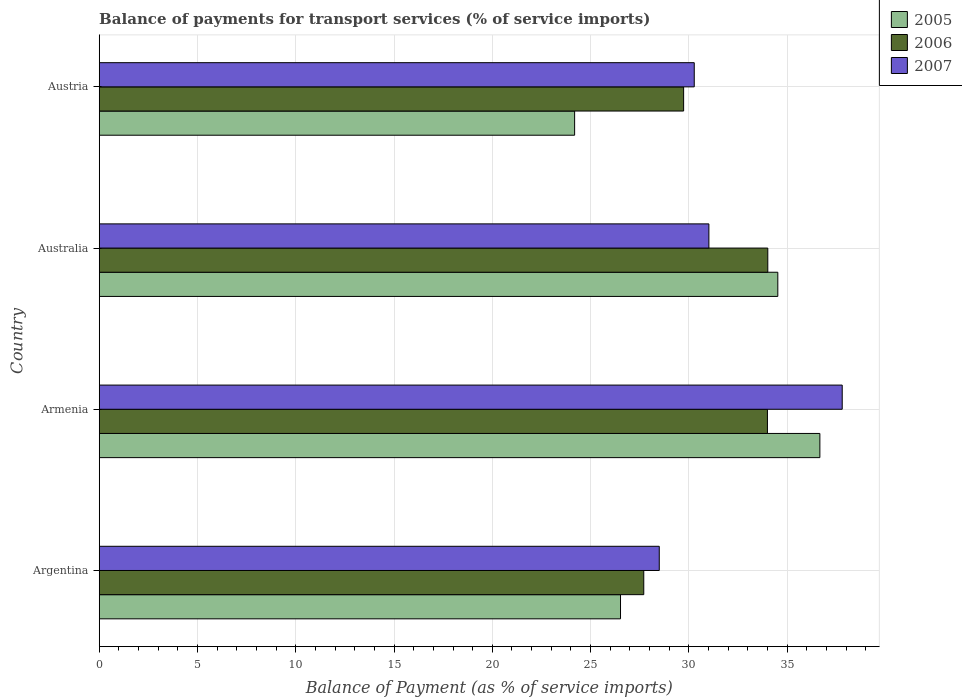How many different coloured bars are there?
Provide a succinct answer. 3. How many groups of bars are there?
Make the answer very short. 4. Are the number of bars on each tick of the Y-axis equal?
Offer a terse response. Yes. How many bars are there on the 1st tick from the bottom?
Your answer should be very brief. 3. In how many cases, is the number of bars for a given country not equal to the number of legend labels?
Your answer should be very brief. 0. What is the balance of payments for transport services in 2006 in Austria?
Your response must be concise. 29.73. Across all countries, what is the maximum balance of payments for transport services in 2006?
Your answer should be compact. 34.02. Across all countries, what is the minimum balance of payments for transport services in 2007?
Make the answer very short. 28.49. In which country was the balance of payments for transport services in 2005 maximum?
Provide a short and direct response. Armenia. What is the total balance of payments for transport services in 2006 in the graph?
Your response must be concise. 125.45. What is the difference between the balance of payments for transport services in 2007 in Argentina and that in Australia?
Make the answer very short. -2.53. What is the difference between the balance of payments for transport services in 2007 in Austria and the balance of payments for transport services in 2005 in Australia?
Provide a short and direct response. -4.25. What is the average balance of payments for transport services in 2007 per country?
Offer a very short reply. 31.9. What is the difference between the balance of payments for transport services in 2006 and balance of payments for transport services in 2005 in Armenia?
Keep it short and to the point. -2.67. In how many countries, is the balance of payments for transport services in 2006 greater than 14 %?
Your response must be concise. 4. What is the ratio of the balance of payments for transport services in 2007 in Armenia to that in Austria?
Provide a short and direct response. 1.25. What is the difference between the highest and the second highest balance of payments for transport services in 2006?
Ensure brevity in your answer.  0.02. What is the difference between the highest and the lowest balance of payments for transport services in 2005?
Provide a succinct answer. 12.48. What does the 1st bar from the bottom in Armenia represents?
Ensure brevity in your answer.  2005. Is it the case that in every country, the sum of the balance of payments for transport services in 2005 and balance of payments for transport services in 2006 is greater than the balance of payments for transport services in 2007?
Offer a terse response. Yes. How many bars are there?
Your answer should be compact. 12. Are all the bars in the graph horizontal?
Give a very brief answer. Yes. Are the values on the major ticks of X-axis written in scientific E-notation?
Provide a succinct answer. No. How many legend labels are there?
Provide a short and direct response. 3. How are the legend labels stacked?
Give a very brief answer. Vertical. What is the title of the graph?
Ensure brevity in your answer.  Balance of payments for transport services (% of service imports). What is the label or title of the X-axis?
Provide a succinct answer. Balance of Payment (as % of service imports). What is the label or title of the Y-axis?
Your response must be concise. Country. What is the Balance of Payment (as % of service imports) of 2005 in Argentina?
Your response must be concise. 26.52. What is the Balance of Payment (as % of service imports) of 2006 in Argentina?
Provide a short and direct response. 27.71. What is the Balance of Payment (as % of service imports) of 2007 in Argentina?
Keep it short and to the point. 28.49. What is the Balance of Payment (as % of service imports) in 2005 in Armenia?
Your answer should be very brief. 36.67. What is the Balance of Payment (as % of service imports) of 2006 in Armenia?
Offer a very short reply. 34. What is the Balance of Payment (as % of service imports) in 2007 in Armenia?
Ensure brevity in your answer.  37.8. What is the Balance of Payment (as % of service imports) in 2005 in Australia?
Provide a succinct answer. 34.53. What is the Balance of Payment (as % of service imports) of 2006 in Australia?
Provide a short and direct response. 34.02. What is the Balance of Payment (as % of service imports) of 2007 in Australia?
Keep it short and to the point. 31.02. What is the Balance of Payment (as % of service imports) in 2005 in Austria?
Your answer should be very brief. 24.19. What is the Balance of Payment (as % of service imports) of 2006 in Austria?
Your answer should be very brief. 29.73. What is the Balance of Payment (as % of service imports) of 2007 in Austria?
Your answer should be very brief. 30.27. Across all countries, what is the maximum Balance of Payment (as % of service imports) in 2005?
Provide a short and direct response. 36.67. Across all countries, what is the maximum Balance of Payment (as % of service imports) of 2006?
Provide a succinct answer. 34.02. Across all countries, what is the maximum Balance of Payment (as % of service imports) of 2007?
Provide a succinct answer. 37.8. Across all countries, what is the minimum Balance of Payment (as % of service imports) of 2005?
Your response must be concise. 24.19. Across all countries, what is the minimum Balance of Payment (as % of service imports) in 2006?
Ensure brevity in your answer.  27.71. Across all countries, what is the minimum Balance of Payment (as % of service imports) in 2007?
Offer a very short reply. 28.49. What is the total Balance of Payment (as % of service imports) of 2005 in the graph?
Keep it short and to the point. 121.9. What is the total Balance of Payment (as % of service imports) in 2006 in the graph?
Offer a very short reply. 125.45. What is the total Balance of Payment (as % of service imports) of 2007 in the graph?
Provide a short and direct response. 127.59. What is the difference between the Balance of Payment (as % of service imports) in 2005 in Argentina and that in Armenia?
Offer a very short reply. -10.14. What is the difference between the Balance of Payment (as % of service imports) of 2006 in Argentina and that in Armenia?
Keep it short and to the point. -6.29. What is the difference between the Balance of Payment (as % of service imports) in 2007 in Argentina and that in Armenia?
Keep it short and to the point. -9.31. What is the difference between the Balance of Payment (as % of service imports) in 2005 in Argentina and that in Australia?
Offer a very short reply. -8. What is the difference between the Balance of Payment (as % of service imports) in 2006 in Argentina and that in Australia?
Your answer should be compact. -6.31. What is the difference between the Balance of Payment (as % of service imports) of 2007 in Argentina and that in Australia?
Your answer should be very brief. -2.53. What is the difference between the Balance of Payment (as % of service imports) of 2005 in Argentina and that in Austria?
Keep it short and to the point. 2.33. What is the difference between the Balance of Payment (as % of service imports) of 2006 in Argentina and that in Austria?
Your answer should be very brief. -2.03. What is the difference between the Balance of Payment (as % of service imports) of 2007 in Argentina and that in Austria?
Offer a terse response. -1.78. What is the difference between the Balance of Payment (as % of service imports) of 2005 in Armenia and that in Australia?
Give a very brief answer. 2.14. What is the difference between the Balance of Payment (as % of service imports) in 2006 in Armenia and that in Australia?
Provide a succinct answer. -0.02. What is the difference between the Balance of Payment (as % of service imports) in 2007 in Armenia and that in Australia?
Provide a short and direct response. 6.78. What is the difference between the Balance of Payment (as % of service imports) in 2005 in Armenia and that in Austria?
Ensure brevity in your answer.  12.48. What is the difference between the Balance of Payment (as % of service imports) of 2006 in Armenia and that in Austria?
Keep it short and to the point. 4.26. What is the difference between the Balance of Payment (as % of service imports) of 2007 in Armenia and that in Austria?
Your response must be concise. 7.53. What is the difference between the Balance of Payment (as % of service imports) in 2005 in Australia and that in Austria?
Your answer should be compact. 10.34. What is the difference between the Balance of Payment (as % of service imports) of 2006 in Australia and that in Austria?
Provide a succinct answer. 4.28. What is the difference between the Balance of Payment (as % of service imports) of 2007 in Australia and that in Austria?
Provide a short and direct response. 0.74. What is the difference between the Balance of Payment (as % of service imports) of 2005 in Argentina and the Balance of Payment (as % of service imports) of 2006 in Armenia?
Make the answer very short. -7.47. What is the difference between the Balance of Payment (as % of service imports) in 2005 in Argentina and the Balance of Payment (as % of service imports) in 2007 in Armenia?
Keep it short and to the point. -11.28. What is the difference between the Balance of Payment (as % of service imports) in 2006 in Argentina and the Balance of Payment (as % of service imports) in 2007 in Armenia?
Provide a succinct answer. -10.1. What is the difference between the Balance of Payment (as % of service imports) in 2005 in Argentina and the Balance of Payment (as % of service imports) in 2006 in Australia?
Keep it short and to the point. -7.49. What is the difference between the Balance of Payment (as % of service imports) of 2005 in Argentina and the Balance of Payment (as % of service imports) of 2007 in Australia?
Offer a terse response. -4.5. What is the difference between the Balance of Payment (as % of service imports) in 2006 in Argentina and the Balance of Payment (as % of service imports) in 2007 in Australia?
Ensure brevity in your answer.  -3.31. What is the difference between the Balance of Payment (as % of service imports) of 2005 in Argentina and the Balance of Payment (as % of service imports) of 2006 in Austria?
Offer a terse response. -3.21. What is the difference between the Balance of Payment (as % of service imports) in 2005 in Argentina and the Balance of Payment (as % of service imports) in 2007 in Austria?
Offer a very short reply. -3.75. What is the difference between the Balance of Payment (as % of service imports) in 2006 in Argentina and the Balance of Payment (as % of service imports) in 2007 in Austria?
Keep it short and to the point. -2.57. What is the difference between the Balance of Payment (as % of service imports) in 2005 in Armenia and the Balance of Payment (as % of service imports) in 2006 in Australia?
Keep it short and to the point. 2.65. What is the difference between the Balance of Payment (as % of service imports) of 2005 in Armenia and the Balance of Payment (as % of service imports) of 2007 in Australia?
Ensure brevity in your answer.  5.65. What is the difference between the Balance of Payment (as % of service imports) in 2006 in Armenia and the Balance of Payment (as % of service imports) in 2007 in Australia?
Offer a very short reply. 2.98. What is the difference between the Balance of Payment (as % of service imports) in 2005 in Armenia and the Balance of Payment (as % of service imports) in 2006 in Austria?
Give a very brief answer. 6.93. What is the difference between the Balance of Payment (as % of service imports) of 2005 in Armenia and the Balance of Payment (as % of service imports) of 2007 in Austria?
Offer a very short reply. 6.39. What is the difference between the Balance of Payment (as % of service imports) in 2006 in Armenia and the Balance of Payment (as % of service imports) in 2007 in Austria?
Provide a succinct answer. 3.72. What is the difference between the Balance of Payment (as % of service imports) in 2005 in Australia and the Balance of Payment (as % of service imports) in 2006 in Austria?
Your response must be concise. 4.79. What is the difference between the Balance of Payment (as % of service imports) in 2005 in Australia and the Balance of Payment (as % of service imports) in 2007 in Austria?
Provide a short and direct response. 4.25. What is the difference between the Balance of Payment (as % of service imports) of 2006 in Australia and the Balance of Payment (as % of service imports) of 2007 in Austria?
Your response must be concise. 3.74. What is the average Balance of Payment (as % of service imports) of 2005 per country?
Ensure brevity in your answer.  30.48. What is the average Balance of Payment (as % of service imports) of 2006 per country?
Give a very brief answer. 31.36. What is the average Balance of Payment (as % of service imports) of 2007 per country?
Provide a short and direct response. 31.9. What is the difference between the Balance of Payment (as % of service imports) of 2005 and Balance of Payment (as % of service imports) of 2006 in Argentina?
Give a very brief answer. -1.18. What is the difference between the Balance of Payment (as % of service imports) in 2005 and Balance of Payment (as % of service imports) in 2007 in Argentina?
Ensure brevity in your answer.  -1.97. What is the difference between the Balance of Payment (as % of service imports) in 2006 and Balance of Payment (as % of service imports) in 2007 in Argentina?
Your response must be concise. -0.79. What is the difference between the Balance of Payment (as % of service imports) of 2005 and Balance of Payment (as % of service imports) of 2006 in Armenia?
Make the answer very short. 2.67. What is the difference between the Balance of Payment (as % of service imports) of 2005 and Balance of Payment (as % of service imports) of 2007 in Armenia?
Your answer should be very brief. -1.14. What is the difference between the Balance of Payment (as % of service imports) in 2006 and Balance of Payment (as % of service imports) in 2007 in Armenia?
Make the answer very short. -3.8. What is the difference between the Balance of Payment (as % of service imports) in 2005 and Balance of Payment (as % of service imports) in 2006 in Australia?
Ensure brevity in your answer.  0.51. What is the difference between the Balance of Payment (as % of service imports) of 2005 and Balance of Payment (as % of service imports) of 2007 in Australia?
Offer a terse response. 3.51. What is the difference between the Balance of Payment (as % of service imports) of 2006 and Balance of Payment (as % of service imports) of 2007 in Australia?
Provide a succinct answer. 3. What is the difference between the Balance of Payment (as % of service imports) of 2005 and Balance of Payment (as % of service imports) of 2006 in Austria?
Your response must be concise. -5.55. What is the difference between the Balance of Payment (as % of service imports) in 2005 and Balance of Payment (as % of service imports) in 2007 in Austria?
Make the answer very short. -6.09. What is the difference between the Balance of Payment (as % of service imports) in 2006 and Balance of Payment (as % of service imports) in 2007 in Austria?
Your answer should be very brief. -0.54. What is the ratio of the Balance of Payment (as % of service imports) of 2005 in Argentina to that in Armenia?
Provide a short and direct response. 0.72. What is the ratio of the Balance of Payment (as % of service imports) in 2006 in Argentina to that in Armenia?
Give a very brief answer. 0.81. What is the ratio of the Balance of Payment (as % of service imports) of 2007 in Argentina to that in Armenia?
Your answer should be compact. 0.75. What is the ratio of the Balance of Payment (as % of service imports) in 2005 in Argentina to that in Australia?
Give a very brief answer. 0.77. What is the ratio of the Balance of Payment (as % of service imports) in 2006 in Argentina to that in Australia?
Provide a short and direct response. 0.81. What is the ratio of the Balance of Payment (as % of service imports) in 2007 in Argentina to that in Australia?
Your answer should be very brief. 0.92. What is the ratio of the Balance of Payment (as % of service imports) of 2005 in Argentina to that in Austria?
Provide a short and direct response. 1.1. What is the ratio of the Balance of Payment (as % of service imports) of 2006 in Argentina to that in Austria?
Your response must be concise. 0.93. What is the ratio of the Balance of Payment (as % of service imports) in 2007 in Argentina to that in Austria?
Your answer should be compact. 0.94. What is the ratio of the Balance of Payment (as % of service imports) of 2005 in Armenia to that in Australia?
Make the answer very short. 1.06. What is the ratio of the Balance of Payment (as % of service imports) of 2006 in Armenia to that in Australia?
Provide a short and direct response. 1. What is the ratio of the Balance of Payment (as % of service imports) in 2007 in Armenia to that in Australia?
Give a very brief answer. 1.22. What is the ratio of the Balance of Payment (as % of service imports) in 2005 in Armenia to that in Austria?
Your answer should be compact. 1.52. What is the ratio of the Balance of Payment (as % of service imports) of 2006 in Armenia to that in Austria?
Your answer should be compact. 1.14. What is the ratio of the Balance of Payment (as % of service imports) of 2007 in Armenia to that in Austria?
Your response must be concise. 1.25. What is the ratio of the Balance of Payment (as % of service imports) of 2005 in Australia to that in Austria?
Offer a terse response. 1.43. What is the ratio of the Balance of Payment (as % of service imports) of 2006 in Australia to that in Austria?
Ensure brevity in your answer.  1.14. What is the ratio of the Balance of Payment (as % of service imports) in 2007 in Australia to that in Austria?
Offer a terse response. 1.02. What is the difference between the highest and the second highest Balance of Payment (as % of service imports) of 2005?
Give a very brief answer. 2.14. What is the difference between the highest and the second highest Balance of Payment (as % of service imports) of 2006?
Provide a succinct answer. 0.02. What is the difference between the highest and the second highest Balance of Payment (as % of service imports) of 2007?
Your answer should be compact. 6.78. What is the difference between the highest and the lowest Balance of Payment (as % of service imports) of 2005?
Provide a short and direct response. 12.48. What is the difference between the highest and the lowest Balance of Payment (as % of service imports) of 2006?
Ensure brevity in your answer.  6.31. What is the difference between the highest and the lowest Balance of Payment (as % of service imports) of 2007?
Provide a short and direct response. 9.31. 